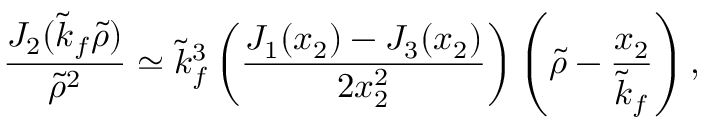Convert formula to latex. <formula><loc_0><loc_0><loc_500><loc_500>\frac { J _ { 2 } ( \tilde { k } _ { f } \tilde { \rho } ) } { \tilde { \rho } ^ { 2 } } \simeq \tilde { k } _ { f } ^ { 3 } \left ( \frac { J _ { 1 } ( x _ { 2 } ) - J _ { 3 } ( x _ { 2 } ) } { 2 x _ { 2 } ^ { 2 } } \right ) \left ( \tilde { \rho } - \frac { x _ { 2 } } { \tilde { k } _ { f } } \right ) ,</formula> 